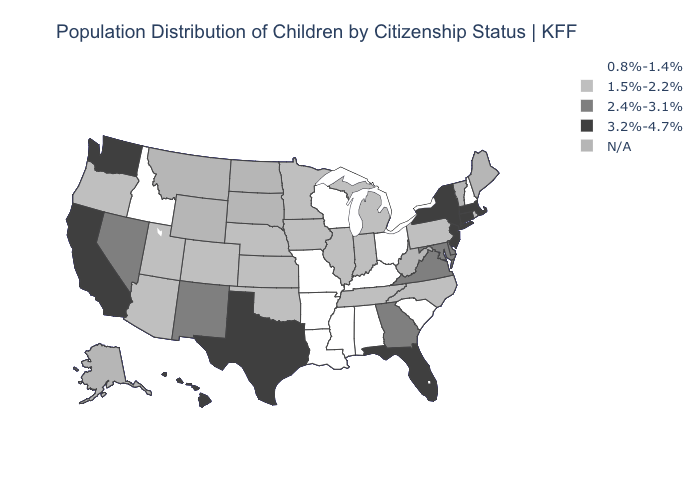Does the map have missing data?
Short answer required. Yes. What is the value of Florida?
Keep it brief. 3.2%-4.7%. Does South Carolina have the lowest value in the USA?
Quick response, please. Yes. Does the map have missing data?
Quick response, please. Yes. What is the lowest value in the West?
Short answer required. 0.8%-1.4%. Name the states that have a value in the range 0.8%-1.4%?
Quick response, please. Alabama, Arkansas, Idaho, Kentucky, Louisiana, Mississippi, Missouri, New Hampshire, Ohio, South Carolina, Wisconsin. Name the states that have a value in the range N/A?
Concise answer only. Alaska, Maine, Montana, North Dakota, South Dakota, Vermont, West Virginia, Wyoming. What is the value of Georgia?
Be succinct. 2.4%-3.1%. What is the lowest value in the USA?
Keep it brief. 0.8%-1.4%. Does Texas have the highest value in the South?
Quick response, please. Yes. How many symbols are there in the legend?
Give a very brief answer. 5. Does Oregon have the highest value in the USA?
Answer briefly. No. What is the value of Delaware?
Concise answer only. 2.4%-3.1%. 